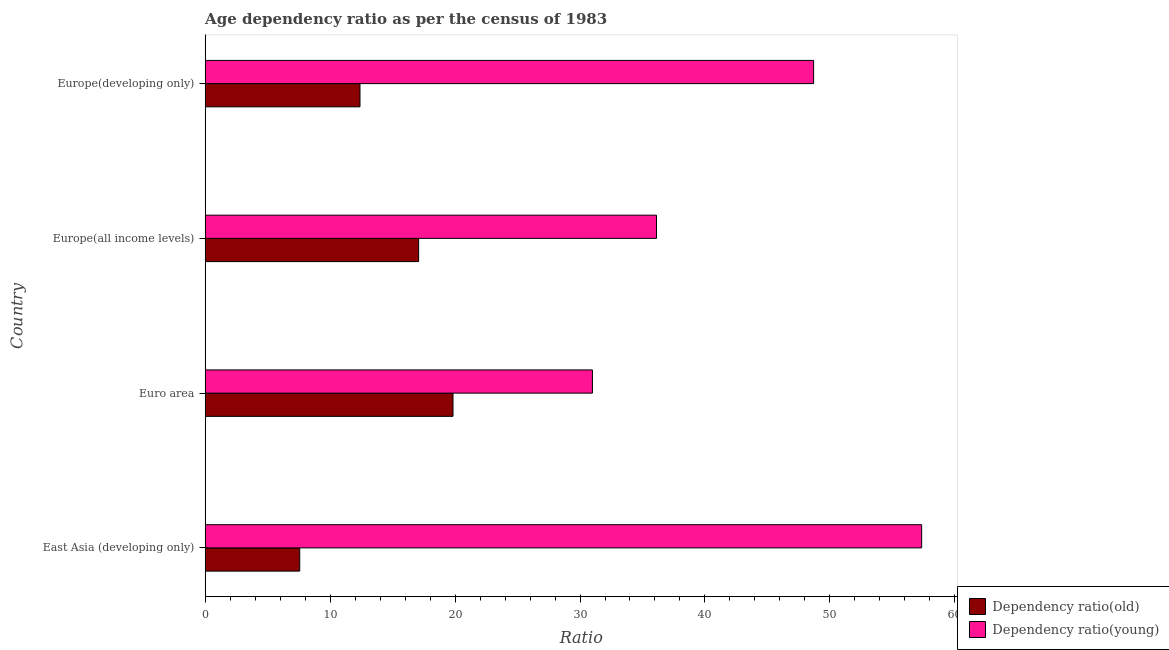How many different coloured bars are there?
Provide a succinct answer. 2. Are the number of bars on each tick of the Y-axis equal?
Your answer should be compact. Yes. How many bars are there on the 4th tick from the top?
Provide a short and direct response. 2. In how many cases, is the number of bars for a given country not equal to the number of legend labels?
Ensure brevity in your answer.  0. What is the age dependency ratio(young) in East Asia (developing only)?
Offer a terse response. 57.35. Across all countries, what is the maximum age dependency ratio(young)?
Offer a terse response. 57.35. Across all countries, what is the minimum age dependency ratio(young)?
Your answer should be very brief. 30.99. In which country was the age dependency ratio(young) maximum?
Make the answer very short. East Asia (developing only). In which country was the age dependency ratio(old) minimum?
Provide a succinct answer. East Asia (developing only). What is the total age dependency ratio(old) in the graph?
Provide a short and direct response. 56.87. What is the difference between the age dependency ratio(young) in East Asia (developing only) and that in Euro area?
Your response must be concise. 26.35. What is the difference between the age dependency ratio(old) in Europe(developing only) and the age dependency ratio(young) in Euro area?
Offer a very short reply. -18.6. What is the average age dependency ratio(old) per country?
Ensure brevity in your answer.  14.22. What is the difference between the age dependency ratio(old) and age dependency ratio(young) in East Asia (developing only)?
Make the answer very short. -49.78. What is the ratio of the age dependency ratio(young) in East Asia (developing only) to that in Europe(all income levels)?
Your answer should be compact. 1.59. Is the age dependency ratio(old) in Europe(all income levels) less than that in Europe(developing only)?
Your response must be concise. No. What is the difference between the highest and the second highest age dependency ratio(young)?
Offer a terse response. 8.65. What is the difference between the highest and the lowest age dependency ratio(old)?
Offer a terse response. 12.27. Is the sum of the age dependency ratio(young) in Euro area and Europe(developing only) greater than the maximum age dependency ratio(old) across all countries?
Offer a terse response. Yes. What does the 1st bar from the top in East Asia (developing only) represents?
Make the answer very short. Dependency ratio(young). What does the 2nd bar from the bottom in Europe(developing only) represents?
Make the answer very short. Dependency ratio(young). Are all the bars in the graph horizontal?
Ensure brevity in your answer.  Yes. Are the values on the major ticks of X-axis written in scientific E-notation?
Offer a very short reply. No. Does the graph contain any zero values?
Keep it short and to the point. No. How many legend labels are there?
Provide a succinct answer. 2. How are the legend labels stacked?
Provide a short and direct response. Vertical. What is the title of the graph?
Your response must be concise. Age dependency ratio as per the census of 1983. Does "Services" appear as one of the legend labels in the graph?
Your response must be concise. No. What is the label or title of the X-axis?
Keep it short and to the point. Ratio. What is the Ratio in Dependency ratio(old) in East Asia (developing only)?
Your response must be concise. 7.57. What is the Ratio in Dependency ratio(young) in East Asia (developing only)?
Give a very brief answer. 57.35. What is the Ratio of Dependency ratio(old) in Euro area?
Offer a very short reply. 19.83. What is the Ratio in Dependency ratio(young) in Euro area?
Keep it short and to the point. 30.99. What is the Ratio of Dependency ratio(old) in Europe(all income levels)?
Keep it short and to the point. 17.08. What is the Ratio of Dependency ratio(young) in Europe(all income levels)?
Offer a terse response. 36.12. What is the Ratio in Dependency ratio(old) in Europe(developing only)?
Ensure brevity in your answer.  12.39. What is the Ratio in Dependency ratio(young) in Europe(developing only)?
Your response must be concise. 48.7. Across all countries, what is the maximum Ratio of Dependency ratio(old)?
Ensure brevity in your answer.  19.83. Across all countries, what is the maximum Ratio of Dependency ratio(young)?
Keep it short and to the point. 57.35. Across all countries, what is the minimum Ratio in Dependency ratio(old)?
Offer a terse response. 7.57. Across all countries, what is the minimum Ratio in Dependency ratio(young)?
Ensure brevity in your answer.  30.99. What is the total Ratio in Dependency ratio(old) in the graph?
Your answer should be very brief. 56.87. What is the total Ratio of Dependency ratio(young) in the graph?
Ensure brevity in your answer.  173.16. What is the difference between the Ratio in Dependency ratio(old) in East Asia (developing only) and that in Euro area?
Ensure brevity in your answer.  -12.27. What is the difference between the Ratio in Dependency ratio(young) in East Asia (developing only) and that in Euro area?
Make the answer very short. 26.35. What is the difference between the Ratio in Dependency ratio(old) in East Asia (developing only) and that in Europe(all income levels)?
Your answer should be very brief. -9.52. What is the difference between the Ratio in Dependency ratio(young) in East Asia (developing only) and that in Europe(all income levels)?
Keep it short and to the point. 21.22. What is the difference between the Ratio of Dependency ratio(old) in East Asia (developing only) and that in Europe(developing only)?
Offer a very short reply. -4.82. What is the difference between the Ratio in Dependency ratio(young) in East Asia (developing only) and that in Europe(developing only)?
Give a very brief answer. 8.65. What is the difference between the Ratio of Dependency ratio(old) in Euro area and that in Europe(all income levels)?
Provide a succinct answer. 2.75. What is the difference between the Ratio in Dependency ratio(young) in Euro area and that in Europe(all income levels)?
Offer a terse response. -5.13. What is the difference between the Ratio of Dependency ratio(old) in Euro area and that in Europe(developing only)?
Offer a terse response. 7.45. What is the difference between the Ratio in Dependency ratio(young) in Euro area and that in Europe(developing only)?
Provide a short and direct response. -17.7. What is the difference between the Ratio of Dependency ratio(old) in Europe(all income levels) and that in Europe(developing only)?
Give a very brief answer. 4.69. What is the difference between the Ratio of Dependency ratio(young) in Europe(all income levels) and that in Europe(developing only)?
Give a very brief answer. -12.58. What is the difference between the Ratio in Dependency ratio(old) in East Asia (developing only) and the Ratio in Dependency ratio(young) in Euro area?
Make the answer very short. -23.43. What is the difference between the Ratio in Dependency ratio(old) in East Asia (developing only) and the Ratio in Dependency ratio(young) in Europe(all income levels)?
Provide a succinct answer. -28.56. What is the difference between the Ratio of Dependency ratio(old) in East Asia (developing only) and the Ratio of Dependency ratio(young) in Europe(developing only)?
Keep it short and to the point. -41.13. What is the difference between the Ratio of Dependency ratio(old) in Euro area and the Ratio of Dependency ratio(young) in Europe(all income levels)?
Ensure brevity in your answer.  -16.29. What is the difference between the Ratio of Dependency ratio(old) in Euro area and the Ratio of Dependency ratio(young) in Europe(developing only)?
Make the answer very short. -28.86. What is the difference between the Ratio in Dependency ratio(old) in Europe(all income levels) and the Ratio in Dependency ratio(young) in Europe(developing only)?
Keep it short and to the point. -31.62. What is the average Ratio of Dependency ratio(old) per country?
Your answer should be very brief. 14.22. What is the average Ratio of Dependency ratio(young) per country?
Your answer should be compact. 43.29. What is the difference between the Ratio of Dependency ratio(old) and Ratio of Dependency ratio(young) in East Asia (developing only)?
Ensure brevity in your answer.  -49.78. What is the difference between the Ratio in Dependency ratio(old) and Ratio in Dependency ratio(young) in Euro area?
Give a very brief answer. -11.16. What is the difference between the Ratio in Dependency ratio(old) and Ratio in Dependency ratio(young) in Europe(all income levels)?
Offer a very short reply. -19.04. What is the difference between the Ratio in Dependency ratio(old) and Ratio in Dependency ratio(young) in Europe(developing only)?
Keep it short and to the point. -36.31. What is the ratio of the Ratio of Dependency ratio(old) in East Asia (developing only) to that in Euro area?
Keep it short and to the point. 0.38. What is the ratio of the Ratio of Dependency ratio(young) in East Asia (developing only) to that in Euro area?
Provide a succinct answer. 1.85. What is the ratio of the Ratio in Dependency ratio(old) in East Asia (developing only) to that in Europe(all income levels)?
Your response must be concise. 0.44. What is the ratio of the Ratio of Dependency ratio(young) in East Asia (developing only) to that in Europe(all income levels)?
Offer a very short reply. 1.59. What is the ratio of the Ratio in Dependency ratio(old) in East Asia (developing only) to that in Europe(developing only)?
Offer a very short reply. 0.61. What is the ratio of the Ratio of Dependency ratio(young) in East Asia (developing only) to that in Europe(developing only)?
Keep it short and to the point. 1.18. What is the ratio of the Ratio in Dependency ratio(old) in Euro area to that in Europe(all income levels)?
Your response must be concise. 1.16. What is the ratio of the Ratio of Dependency ratio(young) in Euro area to that in Europe(all income levels)?
Your answer should be very brief. 0.86. What is the ratio of the Ratio of Dependency ratio(old) in Euro area to that in Europe(developing only)?
Keep it short and to the point. 1.6. What is the ratio of the Ratio of Dependency ratio(young) in Euro area to that in Europe(developing only)?
Give a very brief answer. 0.64. What is the ratio of the Ratio in Dependency ratio(old) in Europe(all income levels) to that in Europe(developing only)?
Give a very brief answer. 1.38. What is the ratio of the Ratio of Dependency ratio(young) in Europe(all income levels) to that in Europe(developing only)?
Your answer should be compact. 0.74. What is the difference between the highest and the second highest Ratio of Dependency ratio(old)?
Offer a terse response. 2.75. What is the difference between the highest and the second highest Ratio in Dependency ratio(young)?
Offer a very short reply. 8.65. What is the difference between the highest and the lowest Ratio of Dependency ratio(old)?
Provide a succinct answer. 12.27. What is the difference between the highest and the lowest Ratio of Dependency ratio(young)?
Offer a very short reply. 26.35. 